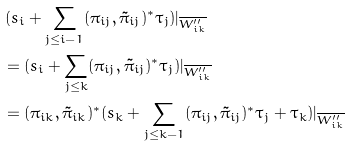Convert formula to latex. <formula><loc_0><loc_0><loc_500><loc_500>& \, ( s _ { i } + \sum _ { j \leq i - 1 } ( \pi _ { i j } , \tilde { \pi } _ { i j } ) ^ { \ast } \tau _ { j } ) | _ { \overline { W ^ { \prime \prime } _ { i k } } } \\ & = ( s _ { i } + \sum _ { j \leq k } ( \pi _ { i j } , \tilde { \pi } _ { i j } ) ^ { \ast } \tau _ { j } ) | _ { \overline { W ^ { \prime \prime } _ { i k } } } \\ & = ( \pi _ { i k } , \tilde { \pi } _ { i k } ) ^ { \ast } ( s _ { k } + \sum _ { j \leq k - 1 } ( \pi _ { i j } , \tilde { \pi } _ { i j } ) ^ { \ast } \tau _ { j } + \tau _ { k } ) | _ { \overline { W ^ { \prime \prime } _ { i k } } }</formula> 